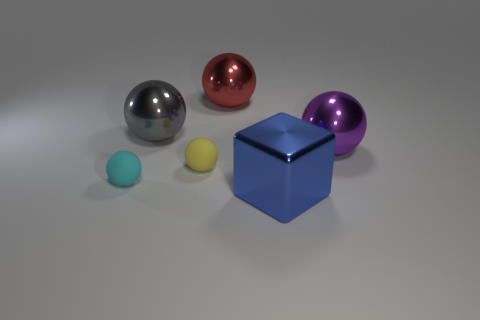Are there more big spheres behind the large purple metal sphere than big balls that are right of the big blue metallic cube?
Offer a very short reply. Yes. There is a cyan thing that is the same size as the yellow rubber ball; what is it made of?
Provide a short and direct response. Rubber. What number of other objects are there of the same material as the small yellow ball?
Give a very brief answer. 1. Does the metallic object that is right of the big blue block have the same shape as the big object in front of the large purple thing?
Provide a succinct answer. No. What number of other objects are there of the same color as the metallic block?
Make the answer very short. 0. Is the material of the big sphere that is right of the blue block the same as the large object to the left of the tiny yellow thing?
Provide a short and direct response. Yes. Is the number of red things that are on the left side of the large gray metallic object the same as the number of small yellow spheres that are in front of the small cyan ball?
Provide a succinct answer. Yes. What material is the small thing that is to the right of the gray ball?
Give a very brief answer. Rubber. Are there fewer large metal cubes than tiny blue metallic spheres?
Your response must be concise. No. What shape is the shiny object that is behind the big purple object and to the right of the large gray metallic ball?
Your answer should be compact. Sphere. 